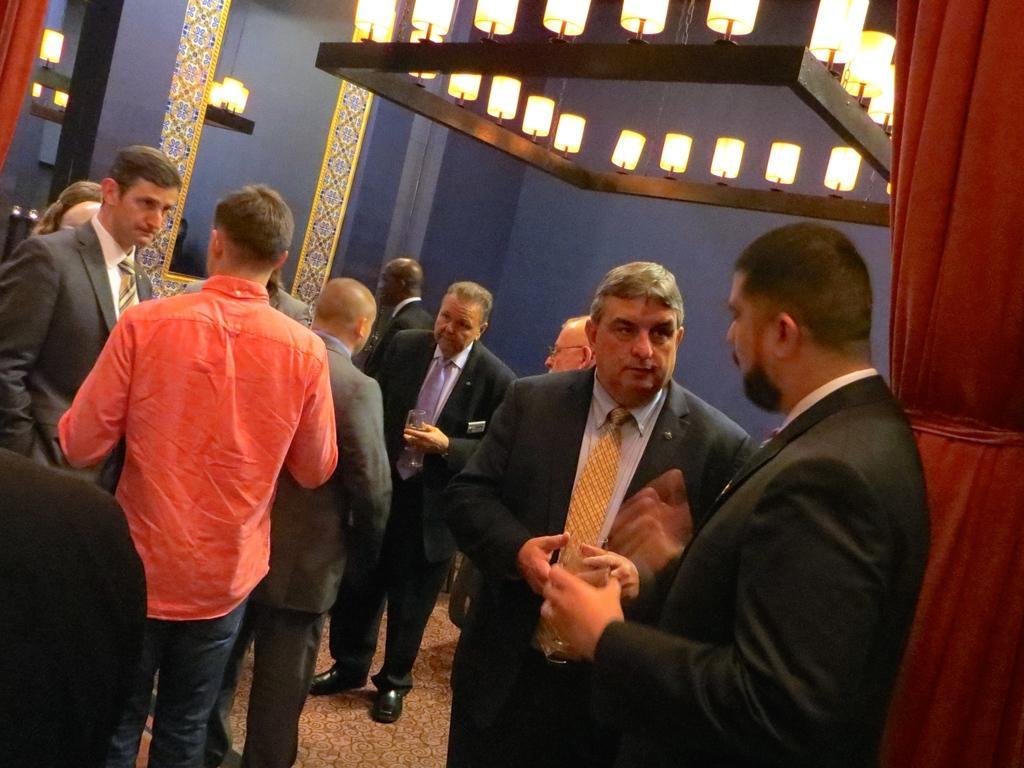Describe this image in one or two sentences. In this picture we can see a group of people standing on the floor were some of them wore blazers, ties and holding glasses with their hands and in the background we can see curtains, lights, walls and some objects. 